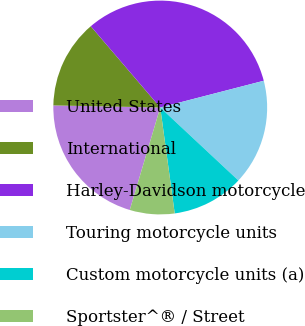Convert chart to OTSL. <chart><loc_0><loc_0><loc_500><loc_500><pie_chart><fcel>United States<fcel>International<fcel>Harley-Davidson motorcycle<fcel>Touring motorcycle units<fcel>Custom motorcycle units (a)<fcel>Sportster^® / Street<nl><fcel>20.71%<fcel>13.43%<fcel>32.23%<fcel>15.98%<fcel>10.88%<fcel>6.76%<nl></chart> 